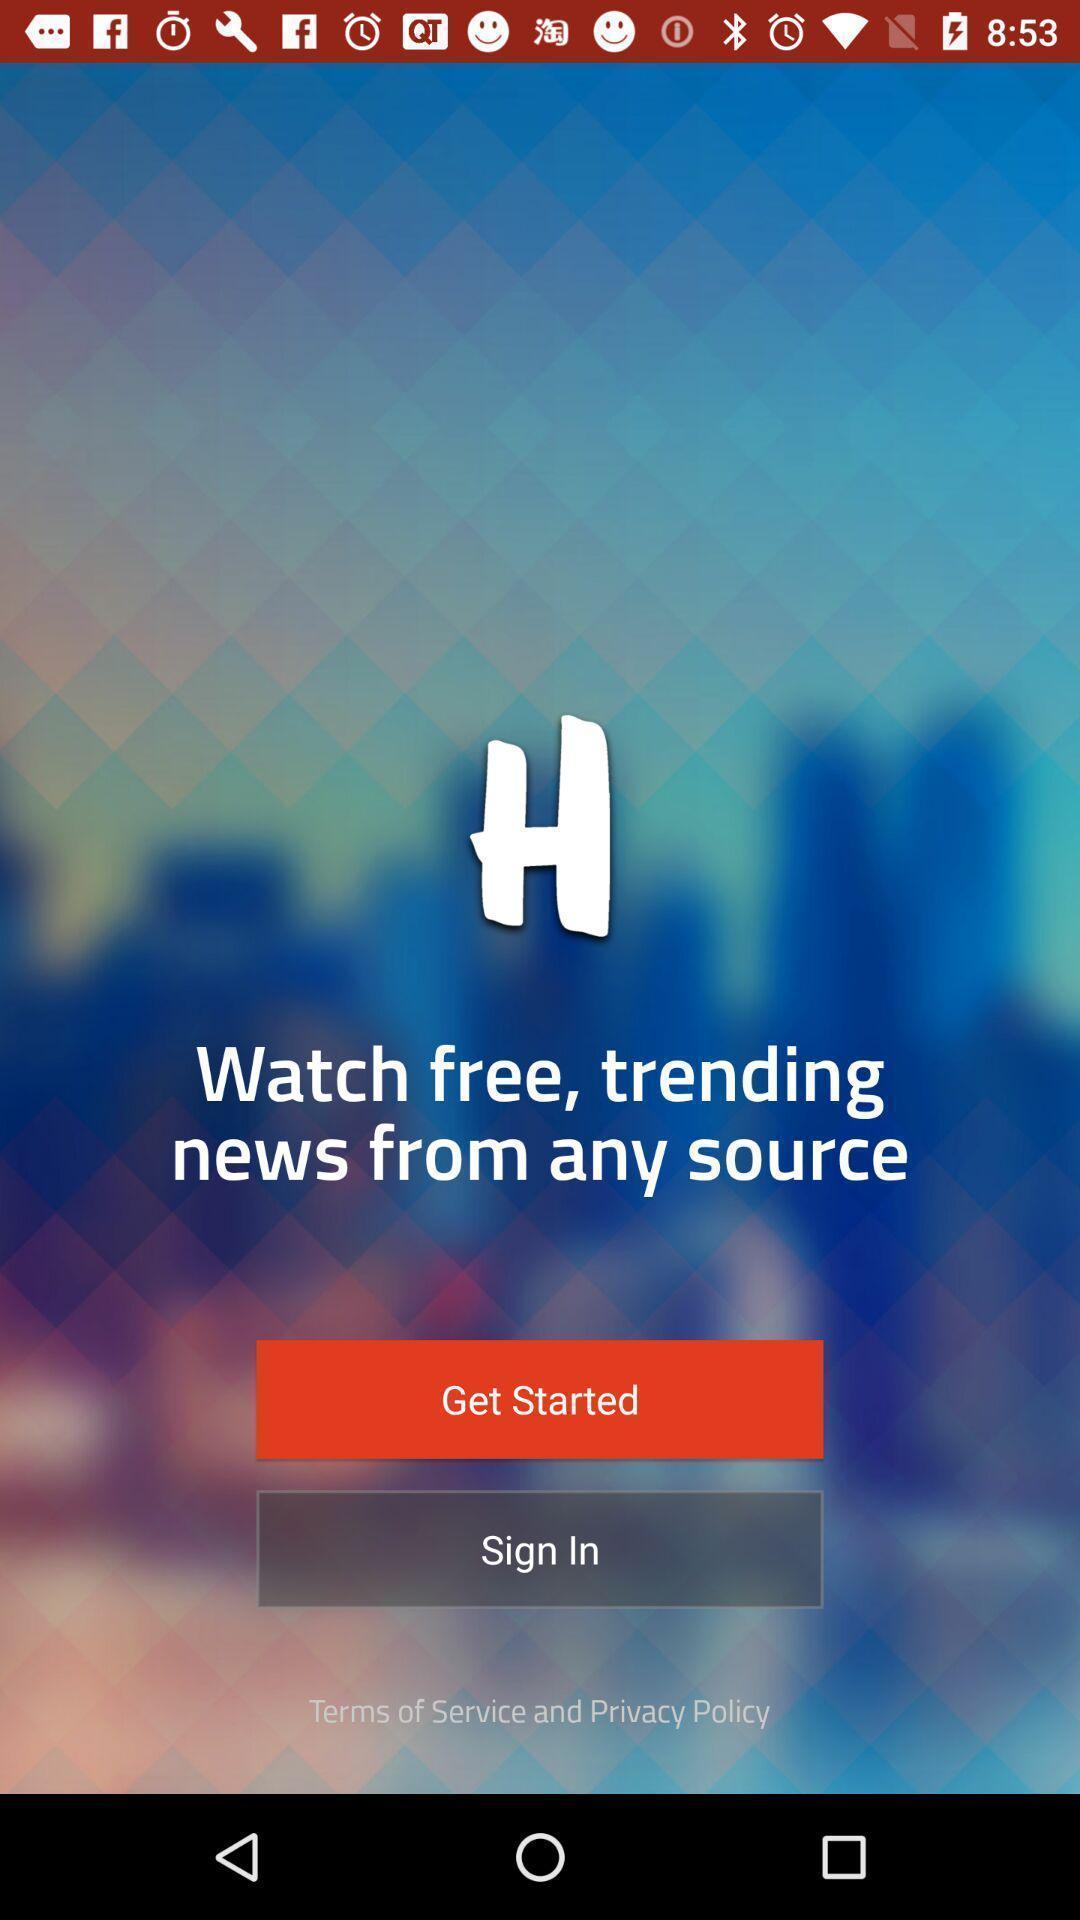What is the overall content of this screenshot? Welcome page of a online tv app. 